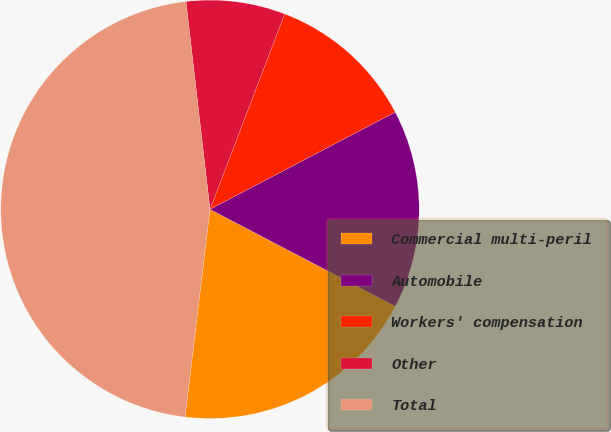<chart> <loc_0><loc_0><loc_500><loc_500><pie_chart><fcel>Commercial multi-peril<fcel>Automobile<fcel>Workers' compensation<fcel>Other<fcel>Total<nl><fcel>19.23%<fcel>15.36%<fcel>11.5%<fcel>7.64%<fcel>46.27%<nl></chart> 